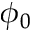Convert formula to latex. <formula><loc_0><loc_0><loc_500><loc_500>\phi _ { 0 }</formula> 